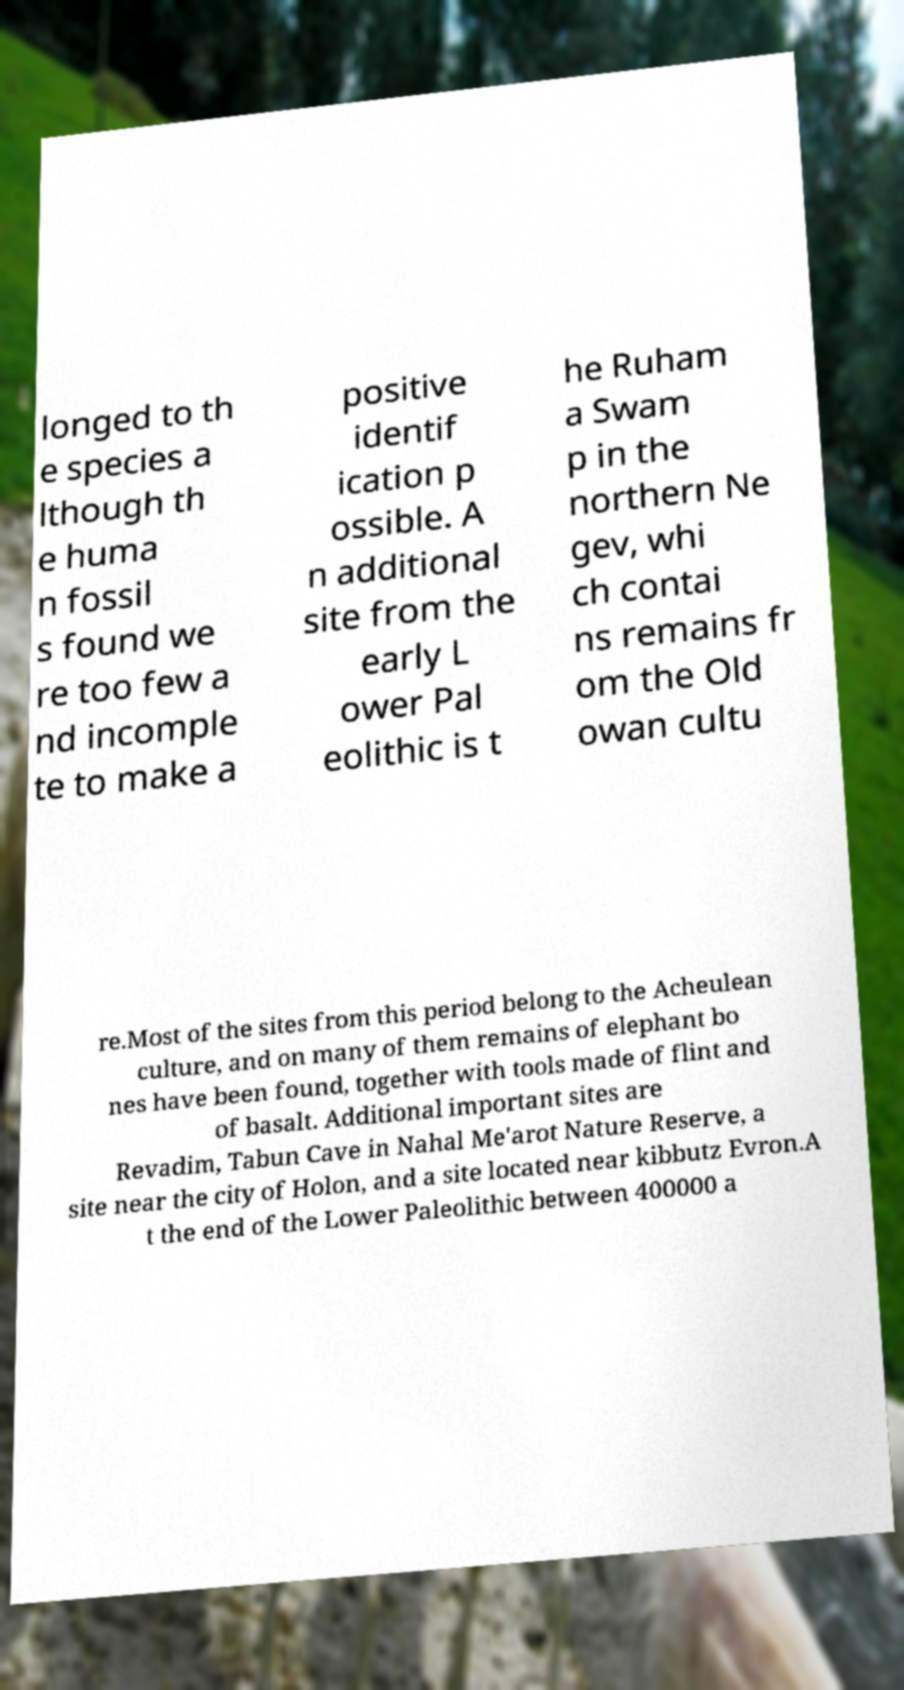Please read and relay the text visible in this image. What does it say? longed to th e species a lthough th e huma n fossil s found we re too few a nd incomple te to make a positive identif ication p ossible. A n additional site from the early L ower Pal eolithic is t he Ruham a Swam p in the northern Ne gev, whi ch contai ns remains fr om the Old owan cultu re.Most of the sites from this period belong to the Acheulean culture, and on many of them remains of elephant bo nes have been found, together with tools made of flint and of basalt. Additional important sites are Revadim, Tabun Cave in Nahal Me'arot Nature Reserve, a site near the city of Holon, and a site located near kibbutz Evron.A t the end of the Lower Paleolithic between 400000 a 